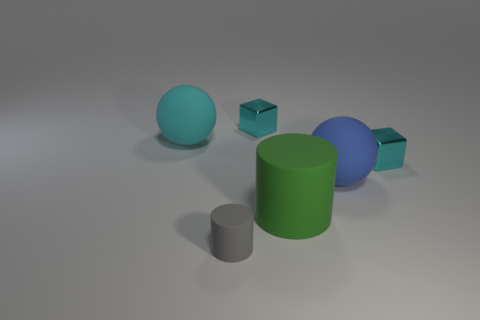Add 2 large red metal cylinders. How many objects exist? 8 Subtract all spheres. How many objects are left? 4 Subtract 1 cyan spheres. How many objects are left? 5 Subtract all tiny red balls. Subtract all large blue rubber spheres. How many objects are left? 5 Add 2 big blue rubber things. How many big blue rubber things are left? 3 Add 2 cyan blocks. How many cyan blocks exist? 4 